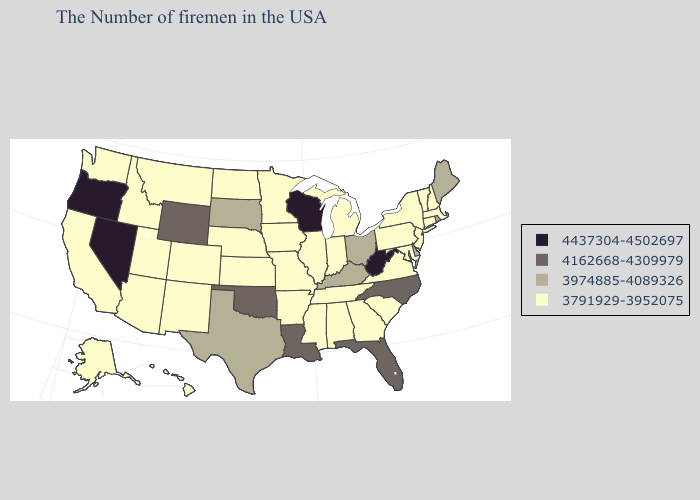Does Alaska have the highest value in the West?
Write a very short answer. No. Which states have the lowest value in the USA?
Short answer required. Massachusetts, New Hampshire, Vermont, Connecticut, New York, New Jersey, Maryland, Pennsylvania, Virginia, South Carolina, Georgia, Michigan, Indiana, Alabama, Tennessee, Illinois, Mississippi, Missouri, Arkansas, Minnesota, Iowa, Kansas, Nebraska, North Dakota, Colorado, New Mexico, Utah, Montana, Arizona, Idaho, California, Washington, Alaska, Hawaii. Does Texas have the highest value in the South?
Short answer required. No. Does the map have missing data?
Concise answer only. No. Name the states that have a value in the range 4437304-4502697?
Concise answer only. West Virginia, Wisconsin, Nevada, Oregon. What is the value of Alabama?
Be succinct. 3791929-3952075. What is the value of South Carolina?
Keep it brief. 3791929-3952075. Which states have the lowest value in the USA?
Concise answer only. Massachusetts, New Hampshire, Vermont, Connecticut, New York, New Jersey, Maryland, Pennsylvania, Virginia, South Carolina, Georgia, Michigan, Indiana, Alabama, Tennessee, Illinois, Mississippi, Missouri, Arkansas, Minnesota, Iowa, Kansas, Nebraska, North Dakota, Colorado, New Mexico, Utah, Montana, Arizona, Idaho, California, Washington, Alaska, Hawaii. Among the states that border Nevada , which have the lowest value?
Give a very brief answer. Utah, Arizona, Idaho, California. Name the states that have a value in the range 3791929-3952075?
Answer briefly. Massachusetts, New Hampshire, Vermont, Connecticut, New York, New Jersey, Maryland, Pennsylvania, Virginia, South Carolina, Georgia, Michigan, Indiana, Alabama, Tennessee, Illinois, Mississippi, Missouri, Arkansas, Minnesota, Iowa, Kansas, Nebraska, North Dakota, Colorado, New Mexico, Utah, Montana, Arizona, Idaho, California, Washington, Alaska, Hawaii. Does Nevada have the highest value in the West?
Keep it brief. Yes. Name the states that have a value in the range 3974885-4089326?
Answer briefly. Maine, Rhode Island, Delaware, Ohio, Kentucky, Texas, South Dakota. Which states have the highest value in the USA?
Write a very short answer. West Virginia, Wisconsin, Nevada, Oregon. What is the highest value in the Northeast ?
Write a very short answer. 3974885-4089326. What is the value of Michigan?
Give a very brief answer. 3791929-3952075. 